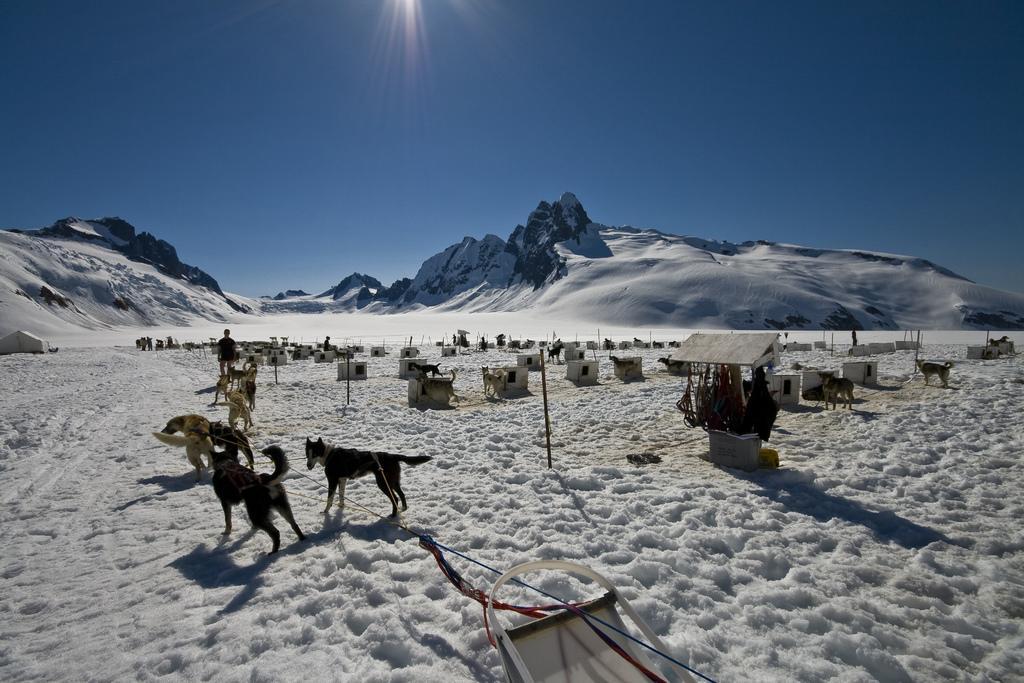Please provide a concise description of this image. In this image there are animals, poles, person, tent, snow, hills, blue sky and objects. Land is covered with snow.  